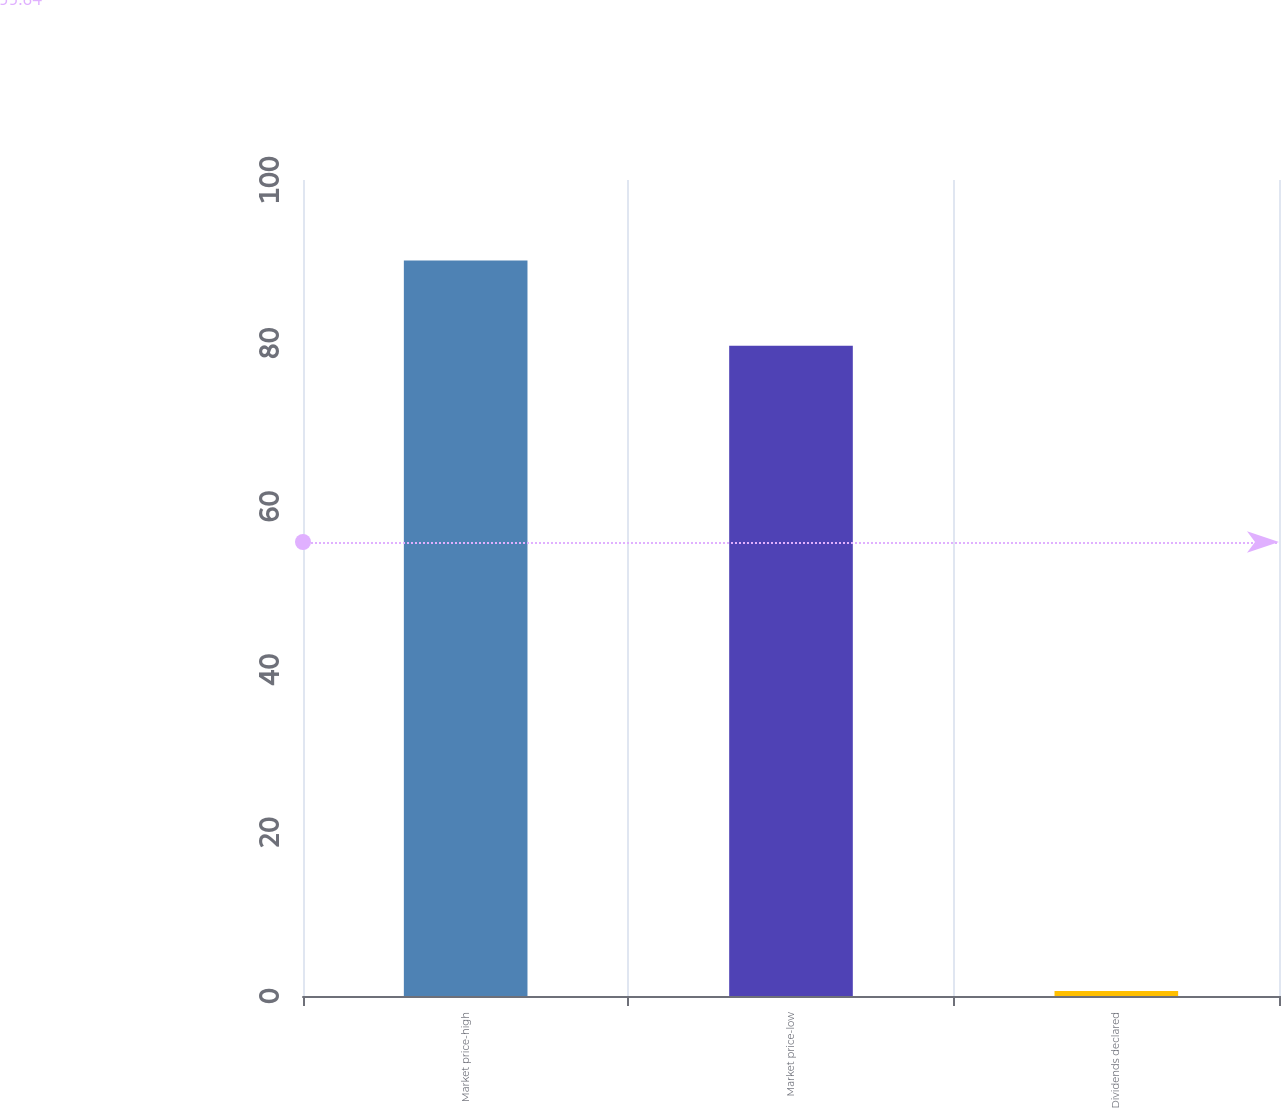<chart> <loc_0><loc_0><loc_500><loc_500><bar_chart><fcel>Market price-high<fcel>Market price-low<fcel>Dividends declared<nl><fcel>90.15<fcel>79.69<fcel>0.6<nl></chart> 